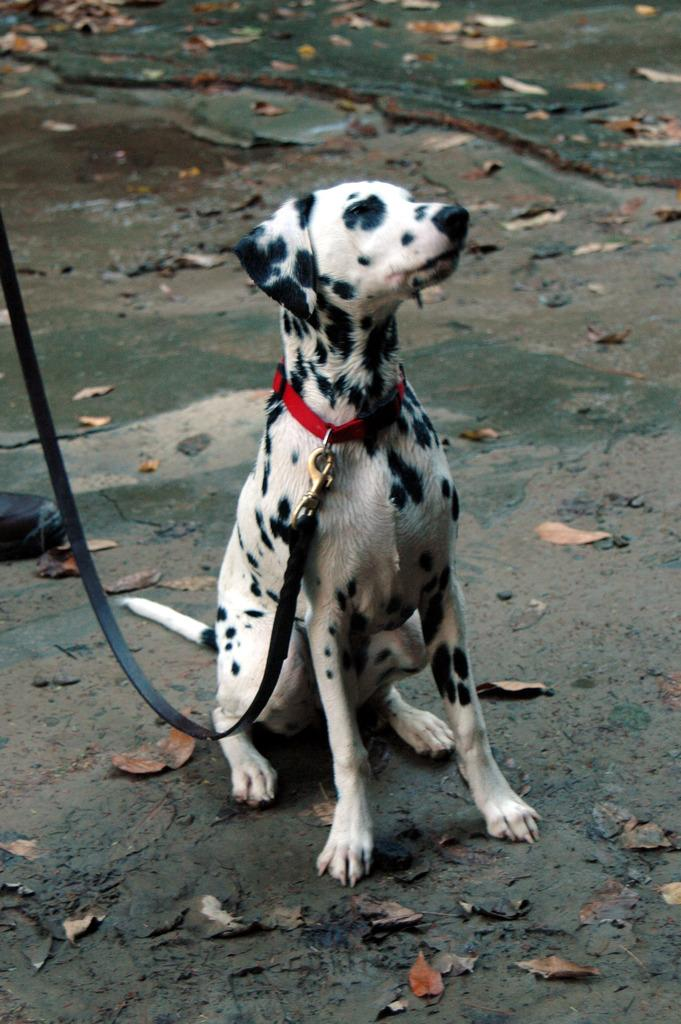What type of animal is in the image? There is a dog in the image. How is the dog being controlled or guided in the image? The dog has a leash. What type of natural debris is present around the dog? Dried leaves are present around the dog. What can be seen on the left side of the image? There is footwear on the left side of the image. What route does the dog take to communicate with the owner in the image? The dog does not take a route to communicate with the owner in the image, as dogs typically communicate through body language and vocalizations rather than following a specific route. 